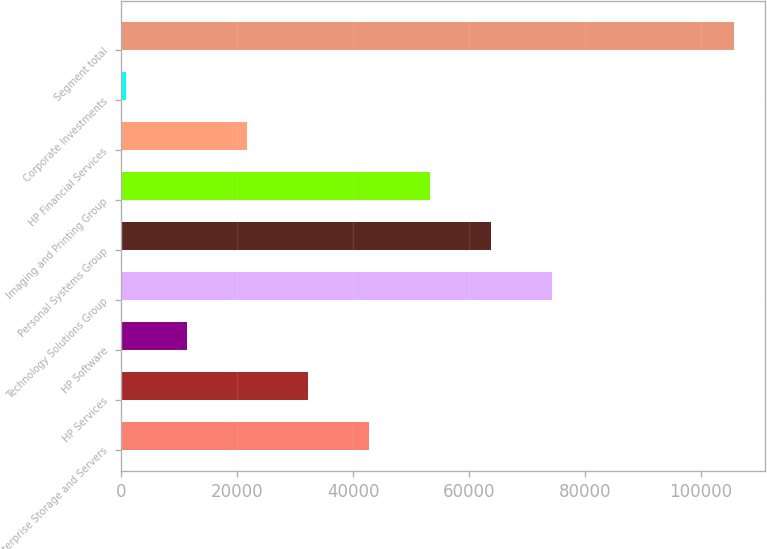Convert chart. <chart><loc_0><loc_0><loc_500><loc_500><bar_chart><fcel>Enterprise Storage and Servers<fcel>HP Services<fcel>HP Software<fcel>Technology Solutions Group<fcel>Personal Systems Group<fcel>Imaging and Printing Group<fcel>HP Financial Services<fcel>Corporate Investments<fcel>Segment total<nl><fcel>42742<fcel>32247<fcel>11257<fcel>74227<fcel>63732<fcel>53237<fcel>21752<fcel>762<fcel>105712<nl></chart> 